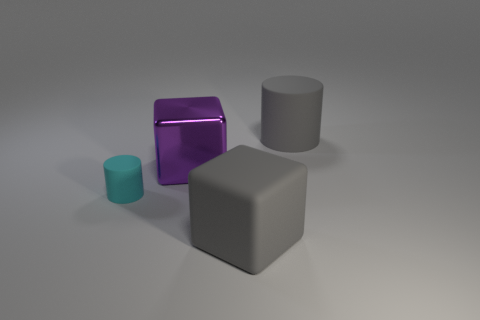The cylinder left of the big gray object that is behind the large gray block is made of what material? While the image suggests a smooth, matte surface for the cylinder, identifying its material with certainty is not possible through visual inspection alone. However, based on its appearance, it resembles a synthetic material such as plastic due to its uniform color and lack of textural details that would indicate a natural material like wood or metal. 